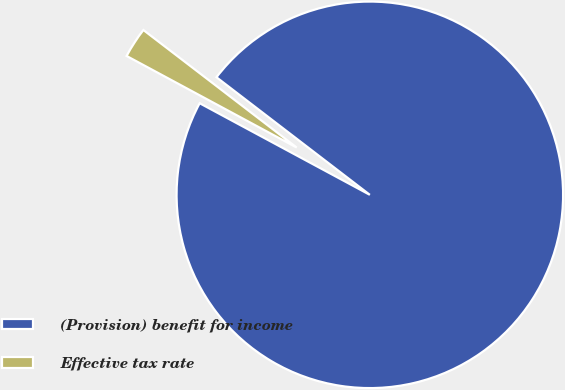Convert chart. <chart><loc_0><loc_0><loc_500><loc_500><pie_chart><fcel>(Provision) benefit for income<fcel>Effective tax rate<nl><fcel>97.45%<fcel>2.55%<nl></chart> 